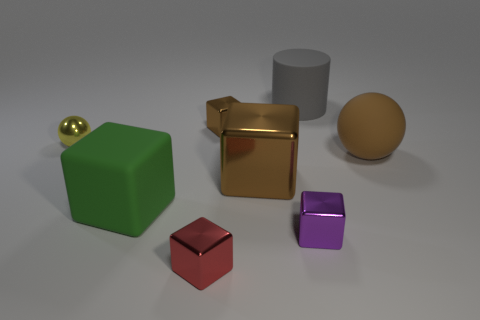How many purple cubes have the same material as the yellow ball?
Give a very brief answer. 1. What material is the tiny brown block?
Ensure brevity in your answer.  Metal. There is a matte thing behind the small thing behind the yellow shiny ball; what is its shape?
Your response must be concise. Cylinder. What is the shape of the small metallic thing that is behind the small yellow metal sphere?
Your response must be concise. Cube. What number of big rubber balls have the same color as the large shiny cube?
Offer a terse response. 1. What is the color of the rubber block?
Provide a succinct answer. Green. What number of brown cubes are to the right of the metallic cube in front of the purple cube?
Your answer should be compact. 2. Do the red metallic cube and the matte object that is behind the big brown sphere have the same size?
Your response must be concise. No. Is the yellow metallic ball the same size as the green object?
Your answer should be compact. No. Is there a gray matte sphere of the same size as the green rubber cube?
Provide a short and direct response. No. 